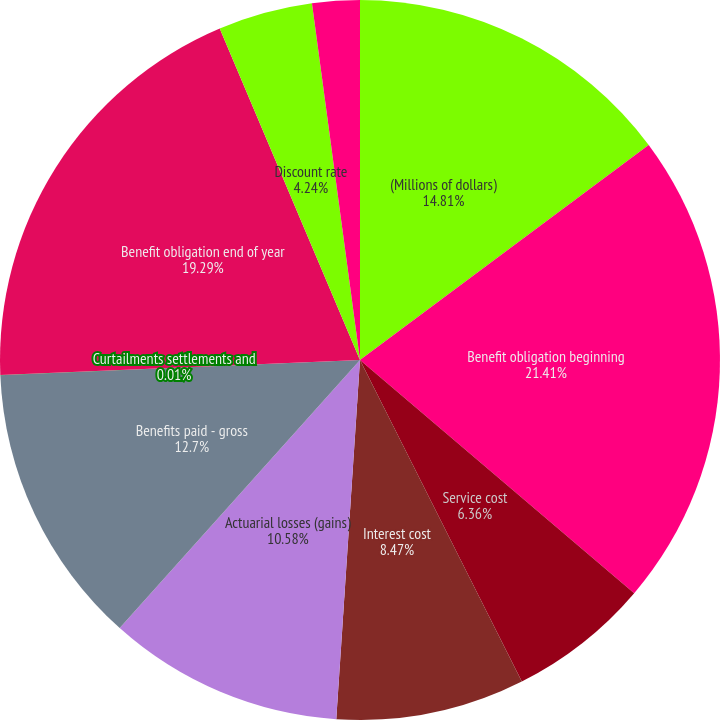Convert chart. <chart><loc_0><loc_0><loc_500><loc_500><pie_chart><fcel>(Millions of dollars)<fcel>Benefit obligation beginning<fcel>Service cost<fcel>Interest cost<fcel>Actuarial losses (gains)<fcel>Benefits paid - gross<fcel>Curtailments settlements and<fcel>Benefit obligation end of year<fcel>Discount rate<fcel>Rate of compensation increase<nl><fcel>14.81%<fcel>21.41%<fcel>6.36%<fcel>8.47%<fcel>10.58%<fcel>12.7%<fcel>0.01%<fcel>19.29%<fcel>4.24%<fcel>2.13%<nl></chart> 